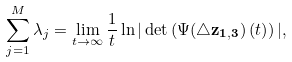Convert formula to latex. <formula><loc_0><loc_0><loc_500><loc_500>\sum _ { j = 1 } ^ { M } \lambda _ { j } = \lim _ { t \to \infty } \frac { 1 } { t } \ln | \det \left ( \Psi ( \triangle \mathbf { z _ { 1 , 3 } } ) \left ( t \right ) \right ) | ,</formula> 